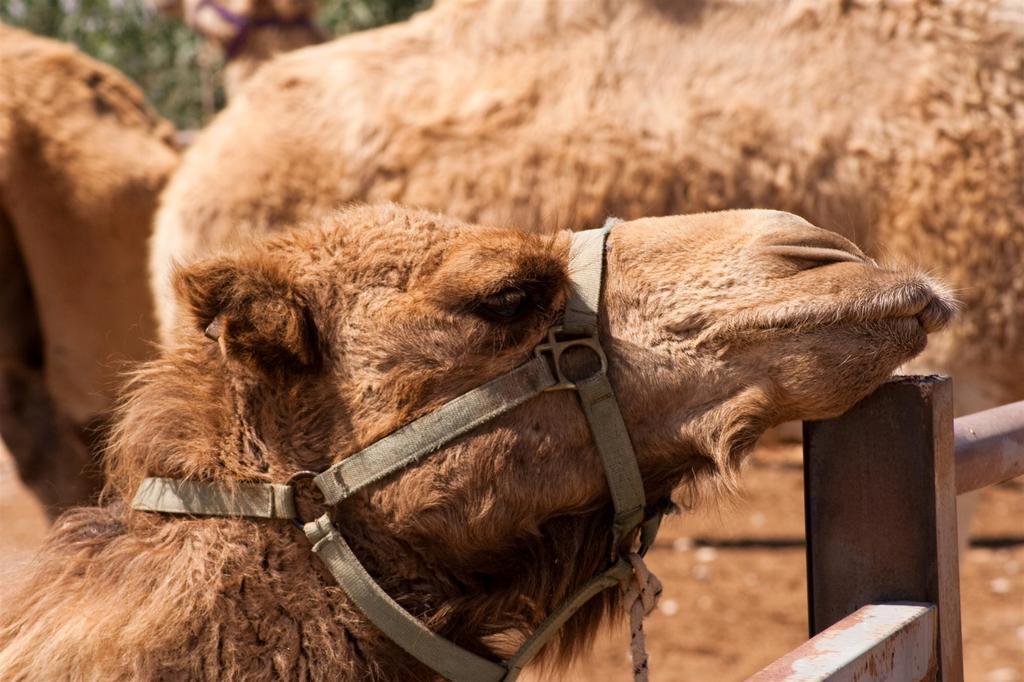How would you summarize this image in a sentence or two? There is a camel which is in brown color placed its head on a rod in front of it and there are few other camels beside it. 